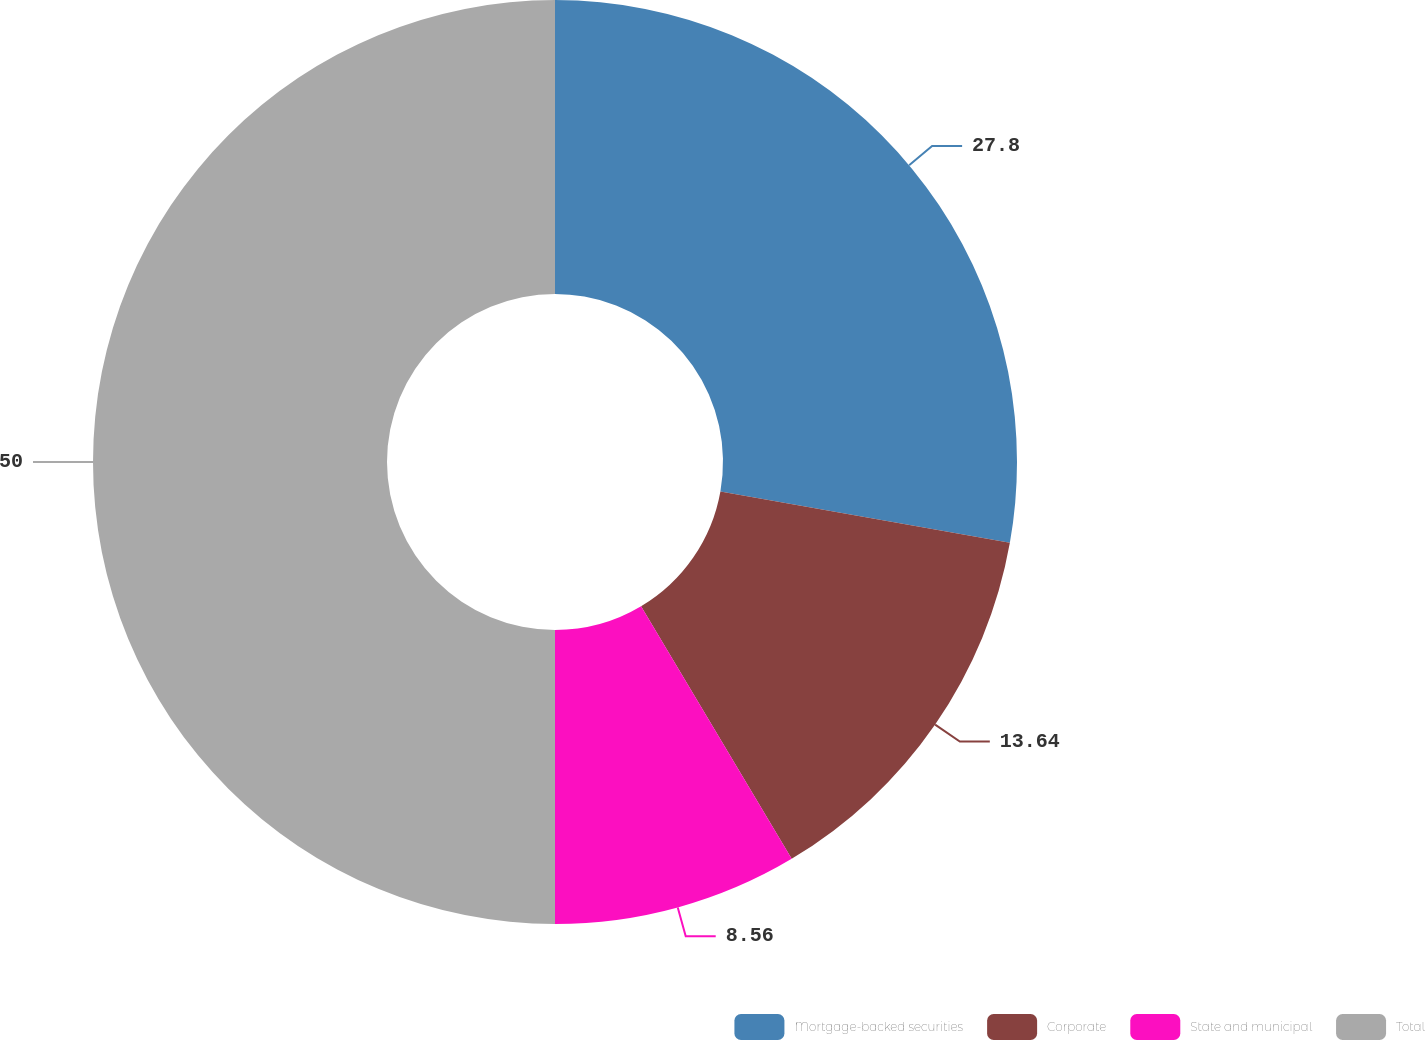Convert chart. <chart><loc_0><loc_0><loc_500><loc_500><pie_chart><fcel>Mortgage-backed securities<fcel>Corporate<fcel>State and municipal<fcel>Total<nl><fcel>27.8%<fcel>13.64%<fcel>8.56%<fcel>50.0%<nl></chart> 